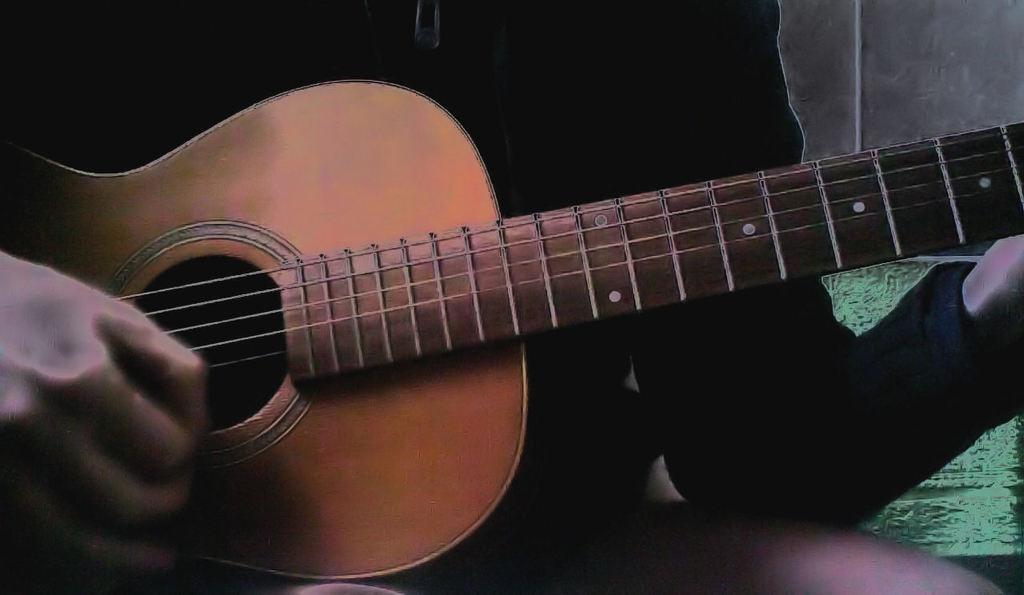How would you summarize this image in a sentence or two? This image is an edited image. In the background there is a wall. In the middle of the image a person is sitting and holding a guitar in the hands and playing music. 